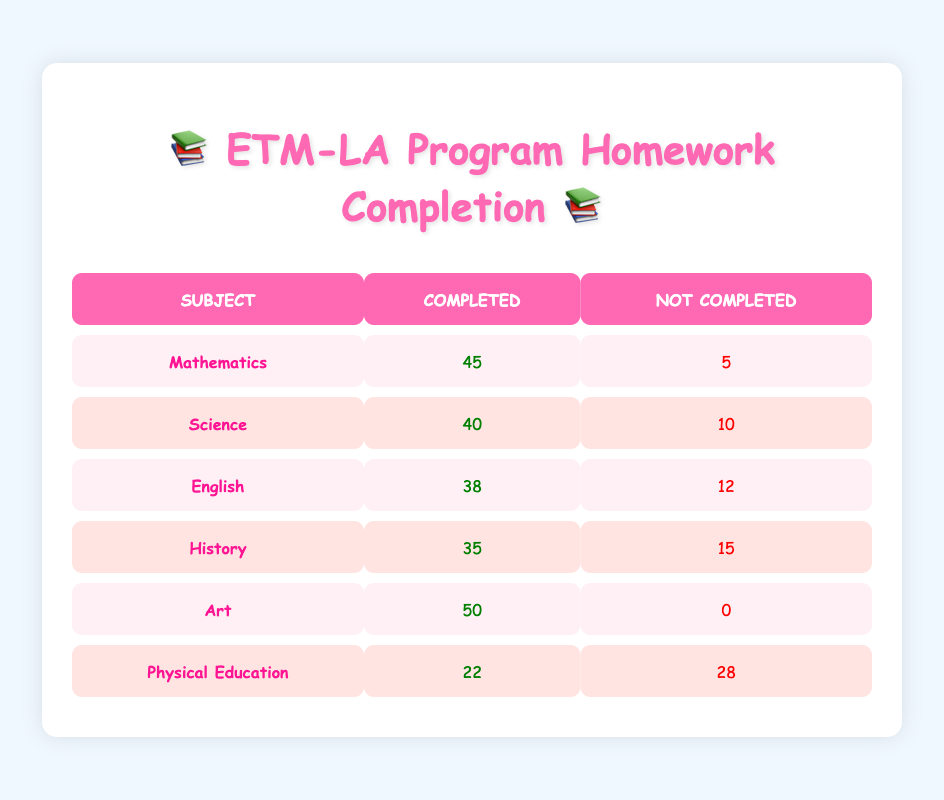What is the total number of students who completed their homework in Mathematics? The table shows that 45 students completed their homework in Mathematics. This is a straightforward retrieval question, answered directly from the data in the table.
Answer: 45 How many students did not complete their homework in Art? According to the table, 0 students did not complete their homework in Art, as it indicates that all students completed their assignments. This is also a straightforward retrieval question.
Answer: 0 Which subject had the highest number of completed homework assignments? From the table, Art has the highest number of completed assignments with 50. This requires a comparison of values in the "Completed" column across all subjects.
Answer: Art What is the total number of students for Physical Education? By adding the number of students who completed (22) and did not complete (28) their homework in Physical Education, we get a total of 50 students (22 + 28 = 50). This involves a simple summation of values from one row.
Answer: 50 Is it true that more students completed homework in Science than in English? The table shows that 40 students completed homework in Science and 38 in English. Since 40 is greater than 38, the statement is true. This is a fact-based question that requires a simple comparison of two values.
Answer: Yes What is the difference between the number of completed homework assignments in Mathematics and History? The table indicates that 45 students completed Mathematics homework, while 35 completed History homework. The difference is 10 (45 - 35 = 10). This is a compositional question involving subtraction.
Answer: 10 What percentage of students completed homework in Physical Education compared to those who did not complete it? To find the percentage of students who completed their homework in Physical Education, first, we note that 22 completed and 28 did not. The total is 50. The percentage is calculated as (22 / 50) * 100 = 44%. This is a complex reasoning question that involves proportion calculation.
Answer: 44% Which subject has the highest percentage of homework completion? To find the subject with the highest percentage of completion, we can calculate the percentage for each subject. For example, Mathematics is (45 / 50) * 100 = 90%, Science is (40 / 50) * 100 = 80%, and so on. After calculating, Art has 100% completion. This involves multiple calculations and comparisons.
Answer: Art How many subjects have more than 30 students who completed their homework? Looking at the completion numbers: Mathematics (45), Science (40), English (38), History (35), and Art (50) all have more than 30 completed assignments. Only Physical Education (22) does not. Thus, 5 subjects exceed 30 completions. This requires counting and filtering based on a threshold.
Answer: 5 